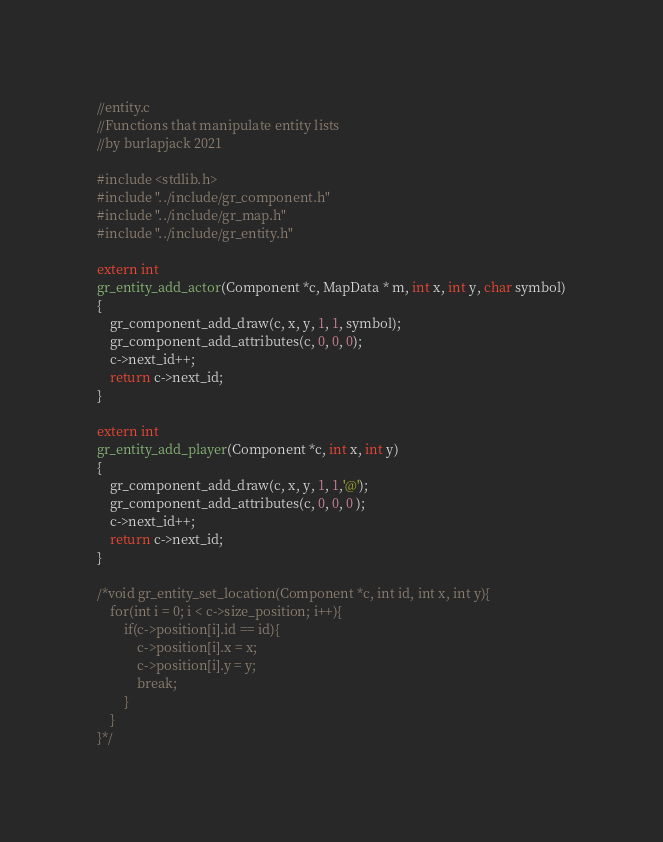<code> <loc_0><loc_0><loc_500><loc_500><_C_>//entity.c
//Functions that manipulate entity lists
//by burlapjack 2021

#include <stdlib.h>
#include "../include/gr_component.h"
#include "../include/gr_map.h"
#include "../include/gr_entity.h"

extern int
gr_entity_add_actor(Component *c, MapData * m, int x, int y, char symbol)
{
	gr_component_add_draw(c, x, y, 1, 1, symbol);
	gr_component_add_attributes(c, 0, 0, 0);
	c->next_id++;
	return c->next_id;
}

extern int
gr_entity_add_player(Component *c, int x, int y)
{
	gr_component_add_draw(c, x, y, 1, 1,'@');
	gr_component_add_attributes(c, 0, 0, 0 );
	c->next_id++;
	return c->next_id;
}

/*void gr_entity_set_location(Component *c, int id, int x, int y){
	for(int i = 0; i < c->size_position; i++){
		if(c->position[i].id == id){
			c->position[i].x = x;
			c->position[i].y = y;
			break;
		}
	}
}*/
</code> 